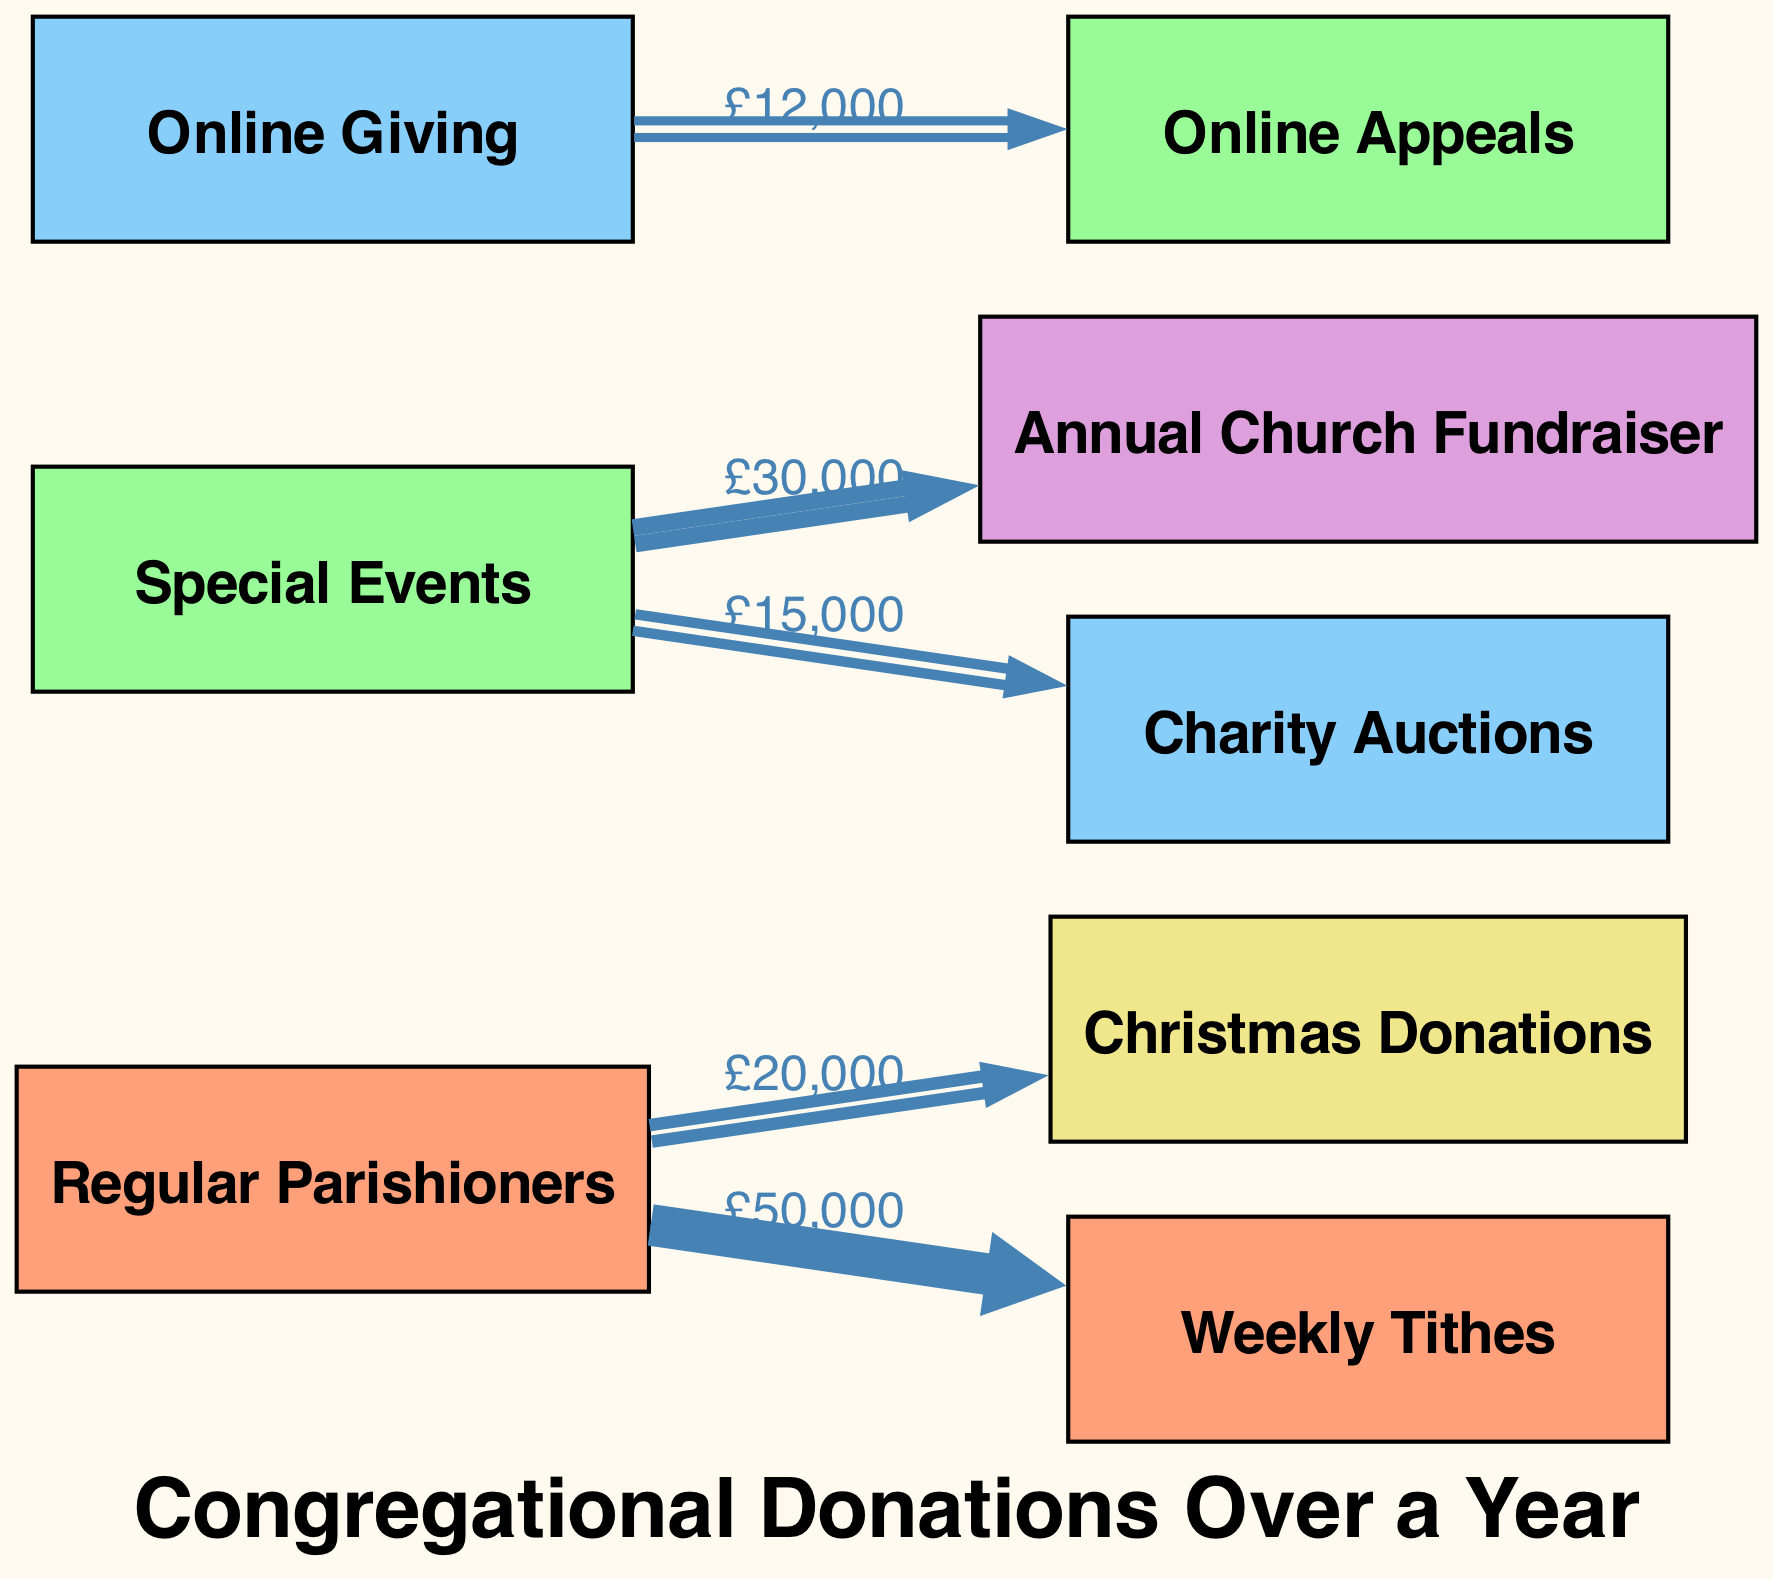What is the total amount contributed by Regular Parishioners? To find this, I need to sum the values of the edges connected to the "Regular Parishioners" node: £50,000 (Weekly Tithes) + £20,000 (Christmas Donations) = £70,000.
Answer: £70,000 How much did the Annual Church Fundraiser contribute? The diagram shows a direct edge from "Special Events" to "Annual Church Fundraiser" with a value of £30,000. Thus, this is the amount contributed.
Answer: £30,000 What is the relationship between Online Giving and Online Appeals? The "Online Giving" node has a direct edge leading to the "Online Appeals" node, which indicates that donations came from Online Giving, valued at £12,000.
Answer: £12,000 Which source had the highest total donations? The total donations can be assessed for each source: Regular Parishioners (£70,000), Special Events (£45,000), and Online Giving (£12,000). Regular Parishioners is the highest at £70,000.
Answer: Regular Parishioners What is the value of the Charity Auctions donations? The diagram indicates that "Special Events" contributed to "Charity Auctions" with a value of £15,000 as shown by their direct edge.
Answer: £15,000 How many nodes are present in the diagram? To find this, I count all unique nodes listed in the data: Regular Parishioners, Special Events, Online Giving, Annual Church Fundraiser, Christmas Donations, Weekly Tithes, Online Appeals, and Charity Auctions, which totals 8 nodes.
Answer: 8 What percentage of the total donations came from Online Giving? First, the total donations amount to £70,000 (Regular Parishioners) + £45,000 (Special Events) + £12,000 (Online Giving) = £127,000. To calculate the percentage from Online Giving: (£12,000 / £127,000) * 100 = 9.45%.
Answer: 9.45% How does the amount from Special Events compare with that from Online Giving? Special Events total £45,000 (from the edges leading to Annual Church Fundraiser and Charity Auctions) compared to Online Giving's total of £12,000. Thus, Special Events received more than Online Giving.
Answer: Special Events Which donation source has the least amount? By reviewing the edge values, Online Giving has the least amount of £12,000 while comparing it with all other sources.
Answer: Online Giving 